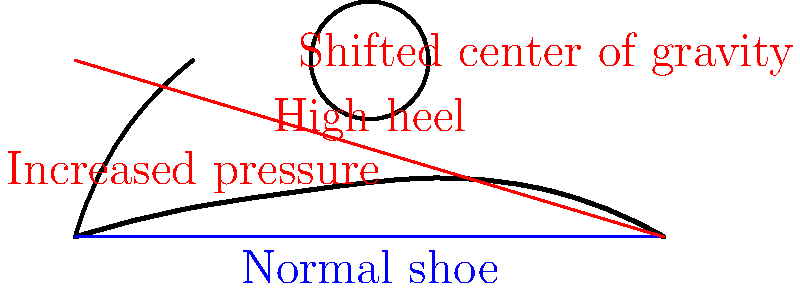Based on the diagram, which of the following biomechanical effects is most likely to occur when wearing high heels compared to normal shoes?

A) Decreased pressure on the forefoot
B) Shifted center of gravity towards the heels
C) Increased pressure on the forefoot and shifted center of gravity forward
D) No significant change in foot biomechanics To answer this question, let's analyze the biomechanical effects of high heels as shown in the diagram:

1. Foot position: 
   - In normal shoes (blue line), the foot is relatively flat.
   - In high heels (red line), the heel is elevated, and the foot is at an angle.

2. Pressure distribution:
   - The diagram indicates "Increased pressure" near the forefoot area when wearing high heels.
   - This is because the angle of the foot shifts more weight onto the ball of the foot and toes.

3. Center of gravity:
   - The diagram shows "Shifted center of gravity" towards the front of the foot when wearing high heels.
   - This shift occurs because the body must compensate for the altered foot position to maintain balance.

4. Overall biomechanics:
   - The change in foot position, pressure distribution, and center of gravity all indicate significant alterations in foot biomechanics when wearing high heels.

Given these observations, the most accurate answer is C) Increased pressure on the forefoot and shifted center of gravity forward. This option correctly identifies both major biomechanical changes illustrated in the diagram.
Answer: C) Increased pressure on the forefoot and shifted center of gravity forward 